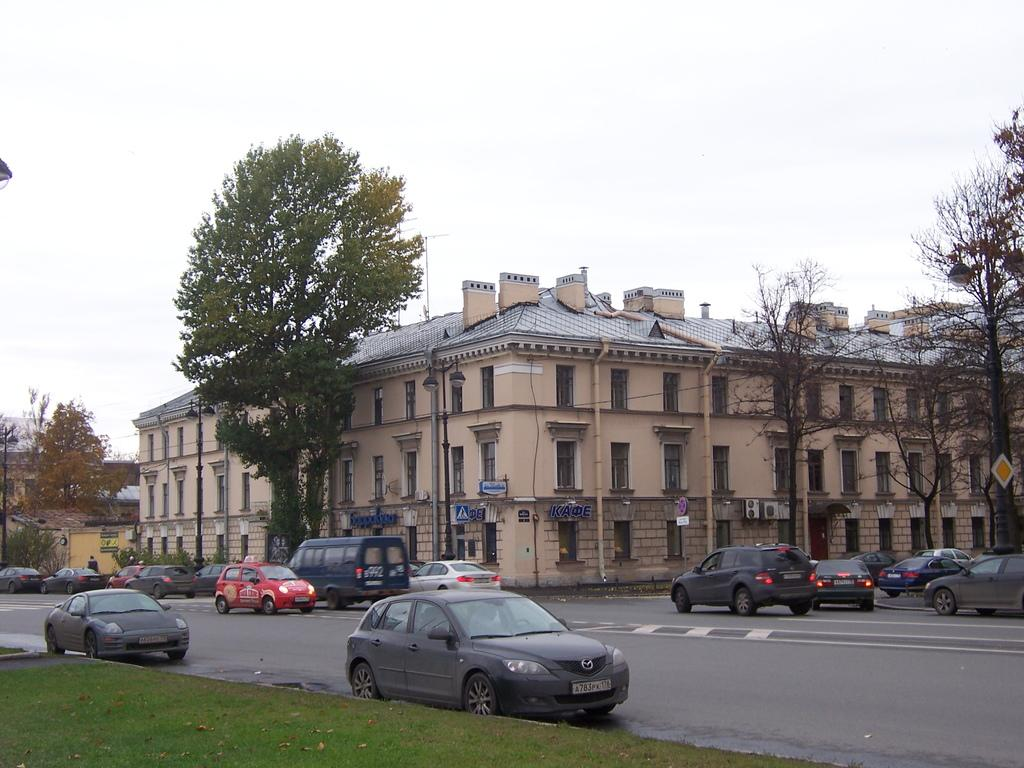What can be seen on the road in the image? There are vehicles on the road in the image. What is visible in the background of the image? The sky, clouds, buildings, windows, poles, trees, and a sign board are visible in the background of the image. What type of vegetation is present in the background of the image? Grass is present in the background of the image. What type of pen is being used to write on the cart in the image? There is no cart or pen present in the image. What tool is being used to fix the wrench in the image? There is no wrench or tool present in the image. 